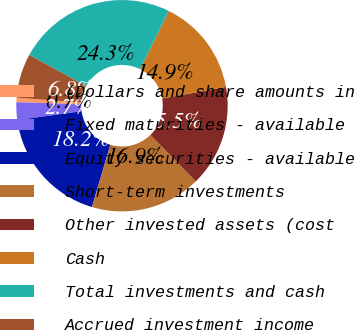Convert chart. <chart><loc_0><loc_0><loc_500><loc_500><pie_chart><fcel>(Dollars and share amounts in<fcel>Fixed maturities - available<fcel>Equity securities - available<fcel>Short-term investments<fcel>Other invested assets (cost<fcel>Cash<fcel>Total investments and cash<fcel>Accrued investment income<nl><fcel>0.68%<fcel>2.7%<fcel>18.24%<fcel>16.89%<fcel>15.54%<fcel>14.86%<fcel>24.32%<fcel>6.76%<nl></chart> 